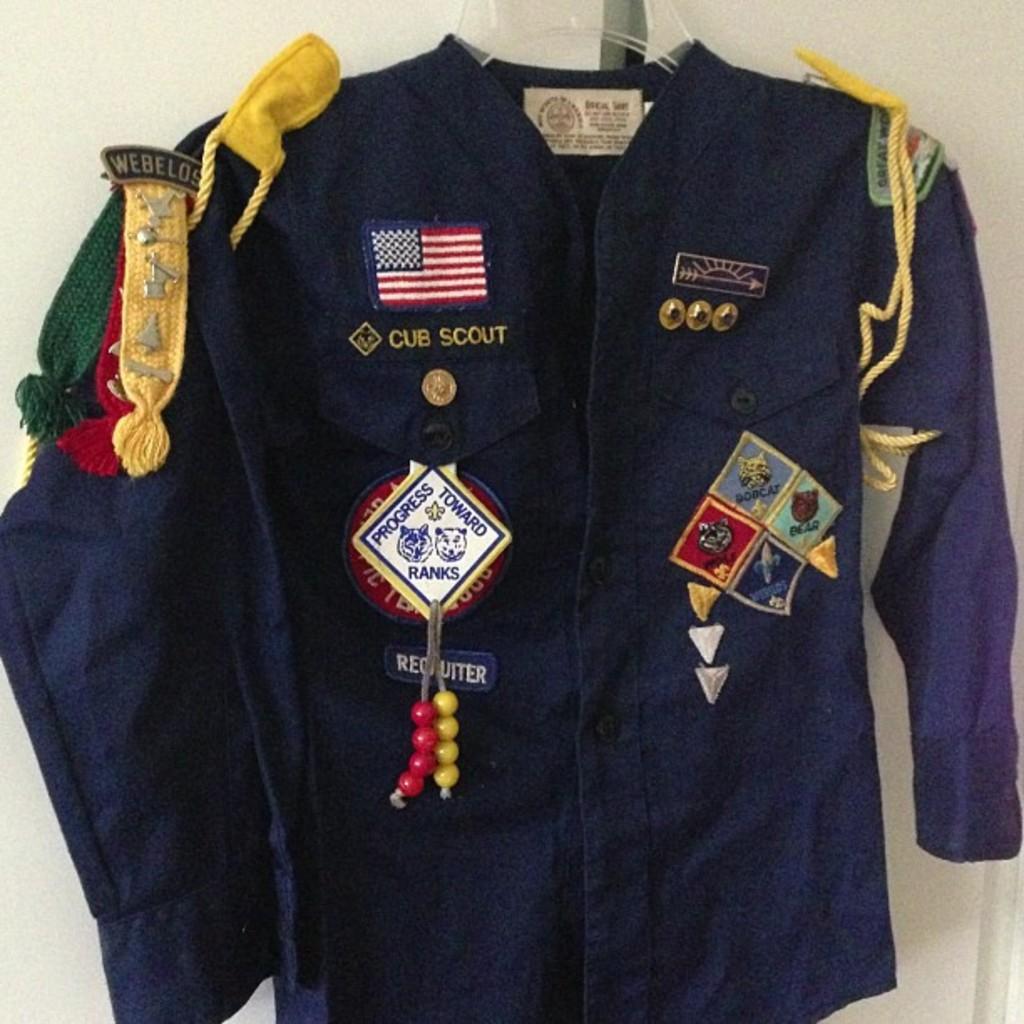What type of uniform is this?
Provide a succinct answer. Cub scout. Is this cub scout an eagle scout now?
Your answer should be compact. No. 